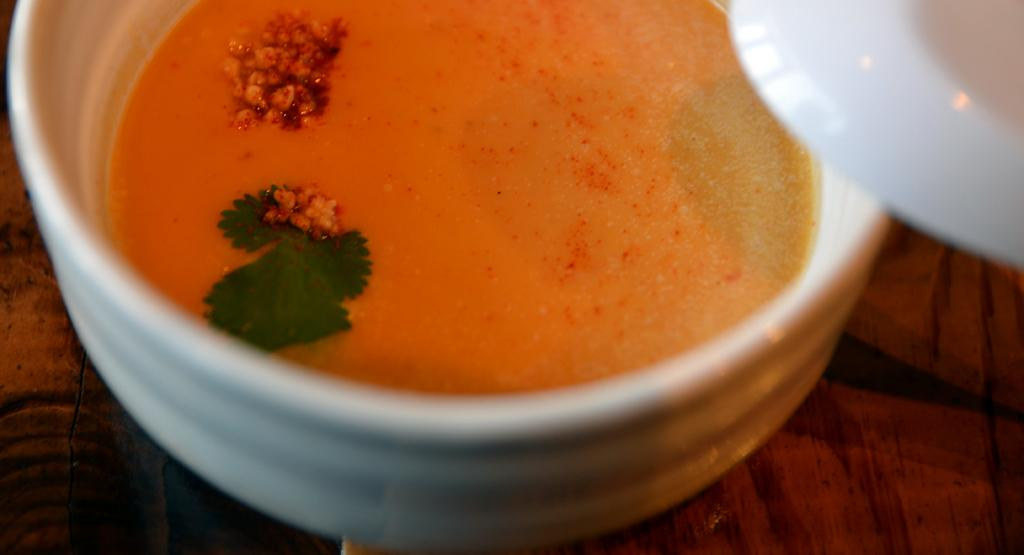What is the main object in the image? There is a wooden plank in the image. What is placed on the wooden plank? There is a white bowl on the wooden plank. What is in the white bowl? The bowl contains soup. What can be found in the soup? The soup has some leaves in it. Is there anything else on top of the bowl? There is a white plate on top of the bowl. What type of pen is being used to write on the cup in the image? There is no cup or pen present in the image. The image features a wooden plank with a white bowl containing soup, and a white plate on top of the bowl. 